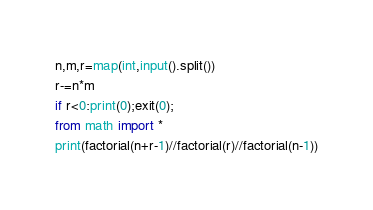Convert code to text. <code><loc_0><loc_0><loc_500><loc_500><_Python_>n,m,r=map(int,input().split())
r-=n*m
if r<0:print(0);exit(0);
from math import *
print(factorial(n+r-1)//factorial(r)//factorial(n-1))</code> 